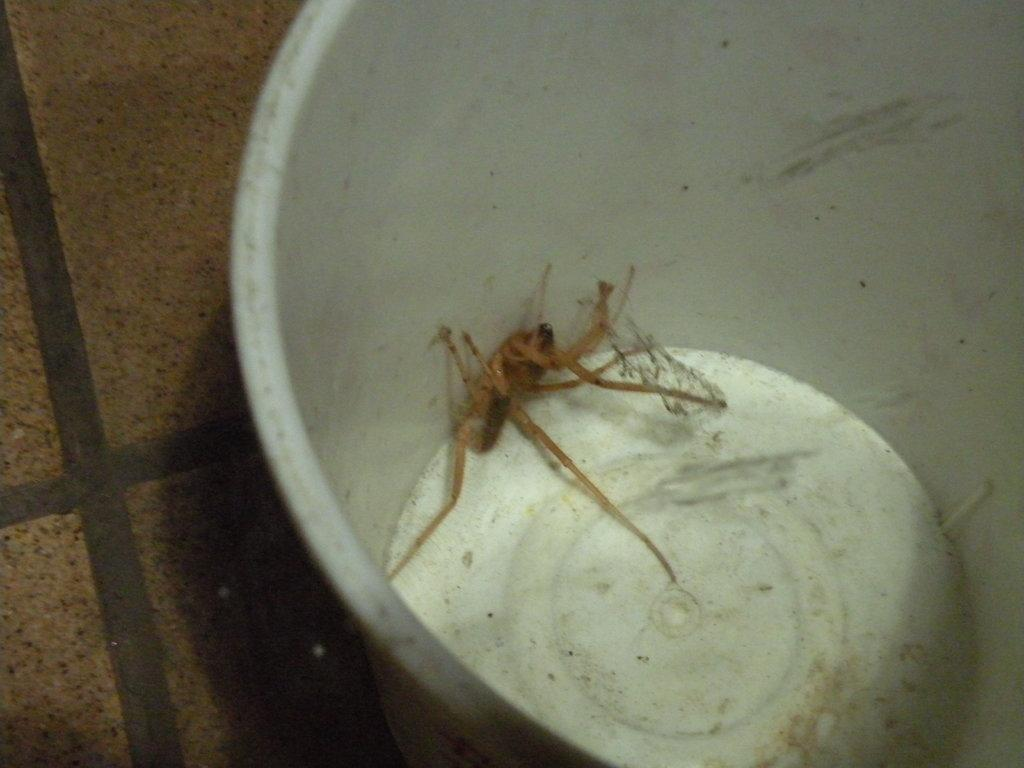What type of creature is in the image? There is an insect in the image. Where is the insect located? The insect is in a cup. What is the position of the cup in the image? The cup is on the floor. What type of chicken is visible in the image? There is no chicken present in the image; it features an insect in a cup on the floor. How does the chalk interact with the insect in the image? There is no chalk present in the image, so it cannot interact with the insect. 